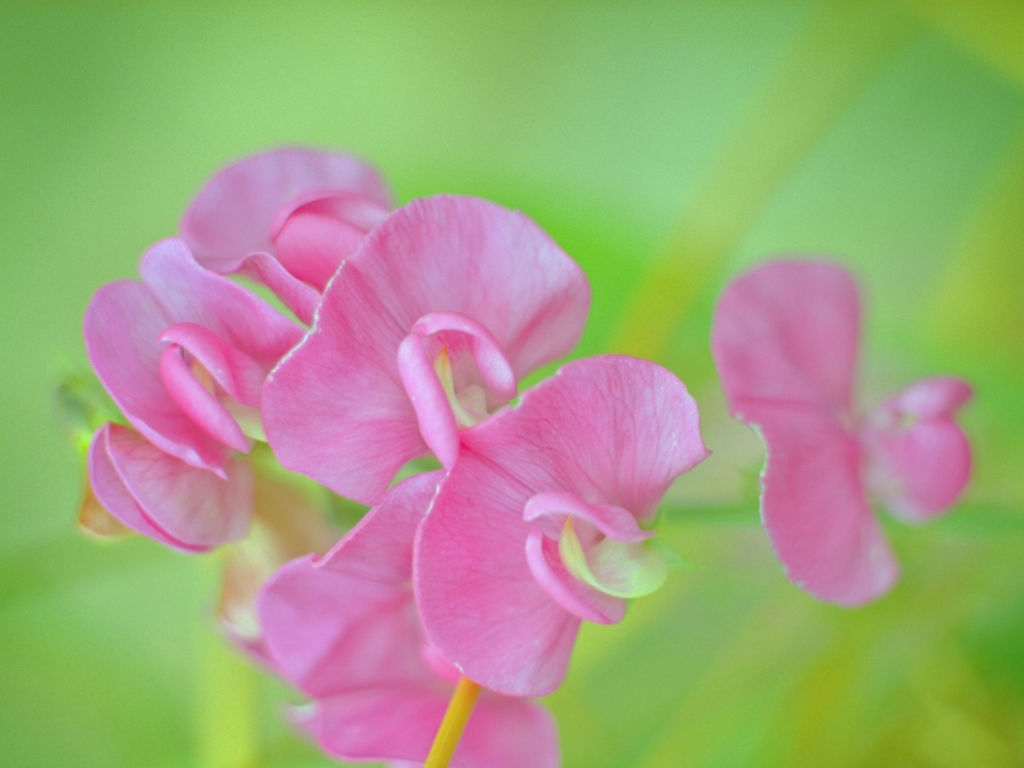Is the focus very good? The focus on the flowers is sharp, which accentuates their delicate texture and vibrant pink hue against the soft green background, creating a lovely depth of field effect. 